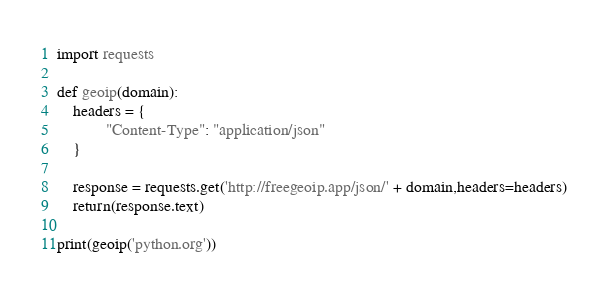<code> <loc_0><loc_0><loc_500><loc_500><_Python_>import requests

def geoip(domain):
	headers = {
            "Content-Type": "application/json"
    }
    
	response = requests.get('http://freegeoip.app/json/' + domain,headers=headers)
	return(response.text)
	
print(geoip('python.org'))
</code> 